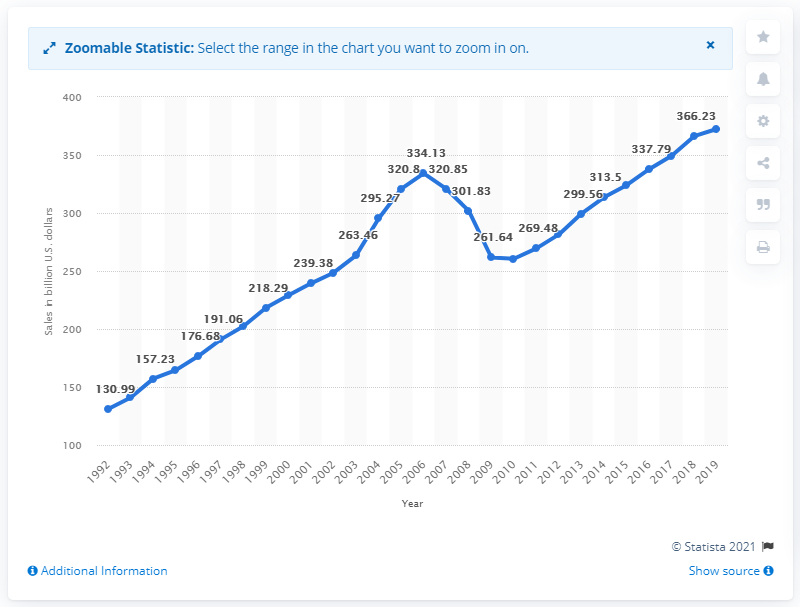Draw attention to some important aspects in this diagram. In the United States in 2019, building material, garden equipment, and supplies dealers sold a total of 372.43 million dollars' worth of products. The sales of building materials, garden equipment, and supplies from the previous year were 366.23... According to the provided information, it can be stated that building material, garden equipment, and supplies stores began to show an upward trend in their sales in the year 2010. The sales of building materials, garden equipment, and supplies from the previous year were 366.23...". 